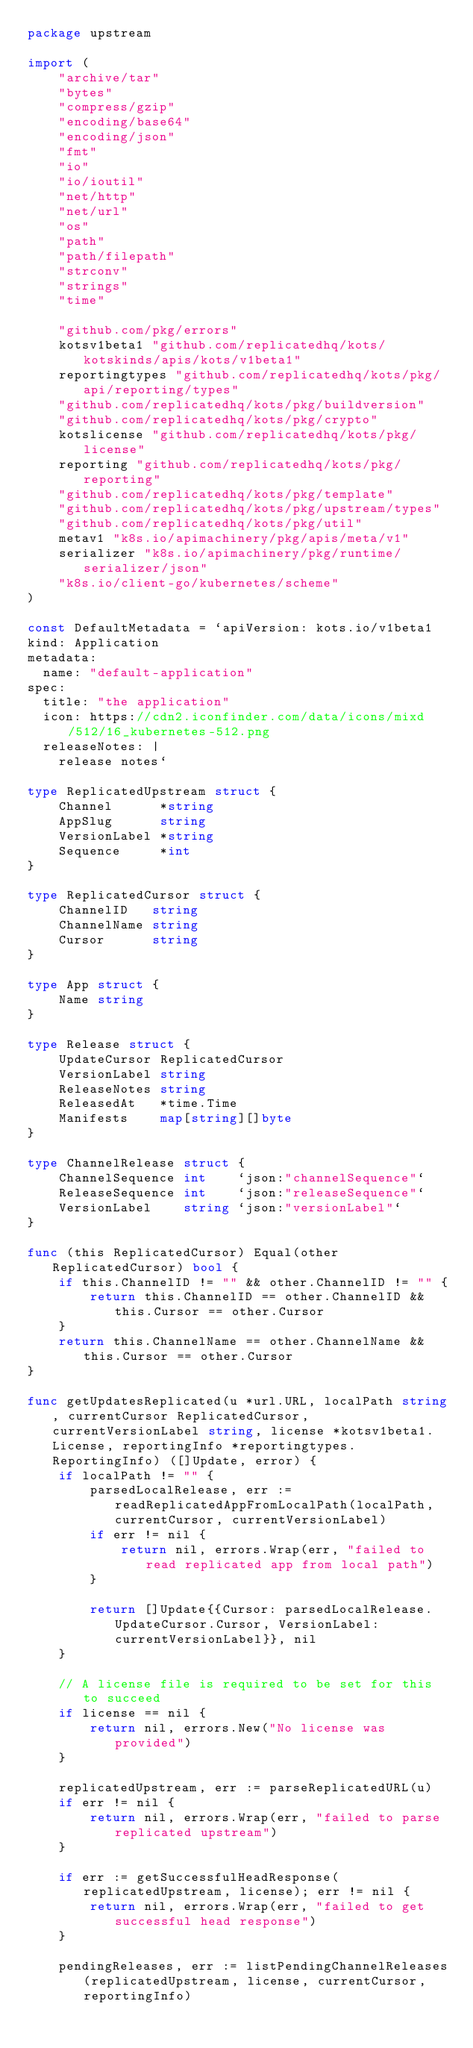Convert code to text. <code><loc_0><loc_0><loc_500><loc_500><_Go_>package upstream

import (
	"archive/tar"
	"bytes"
	"compress/gzip"
	"encoding/base64"
	"encoding/json"
	"fmt"
	"io"
	"io/ioutil"
	"net/http"
	"net/url"
	"os"
	"path"
	"path/filepath"
	"strconv"
	"strings"
	"time"

	"github.com/pkg/errors"
	kotsv1beta1 "github.com/replicatedhq/kots/kotskinds/apis/kots/v1beta1"
	reportingtypes "github.com/replicatedhq/kots/pkg/api/reporting/types"
	"github.com/replicatedhq/kots/pkg/buildversion"
	"github.com/replicatedhq/kots/pkg/crypto"
	kotslicense "github.com/replicatedhq/kots/pkg/license"
	reporting "github.com/replicatedhq/kots/pkg/reporting"
	"github.com/replicatedhq/kots/pkg/template"
	"github.com/replicatedhq/kots/pkg/upstream/types"
	"github.com/replicatedhq/kots/pkg/util"
	metav1 "k8s.io/apimachinery/pkg/apis/meta/v1"
	serializer "k8s.io/apimachinery/pkg/runtime/serializer/json"
	"k8s.io/client-go/kubernetes/scheme"
)

const DefaultMetadata = `apiVersion: kots.io/v1beta1
kind: Application
metadata:
  name: "default-application"
spec:
  title: "the application"
  icon: https://cdn2.iconfinder.com/data/icons/mixd/512/16_kubernetes-512.png
  releaseNotes: |
    release notes`

type ReplicatedUpstream struct {
	Channel      *string
	AppSlug      string
	VersionLabel *string
	Sequence     *int
}

type ReplicatedCursor struct {
	ChannelID   string
	ChannelName string
	Cursor      string
}

type App struct {
	Name string
}

type Release struct {
	UpdateCursor ReplicatedCursor
	VersionLabel string
	ReleaseNotes string
	ReleasedAt   *time.Time
	Manifests    map[string][]byte
}

type ChannelRelease struct {
	ChannelSequence int    `json:"channelSequence"`
	ReleaseSequence int    `json:"releaseSequence"`
	VersionLabel    string `json:"versionLabel"`
}

func (this ReplicatedCursor) Equal(other ReplicatedCursor) bool {
	if this.ChannelID != "" && other.ChannelID != "" {
		return this.ChannelID == other.ChannelID && this.Cursor == other.Cursor
	}
	return this.ChannelName == other.ChannelName && this.Cursor == other.Cursor
}

func getUpdatesReplicated(u *url.URL, localPath string, currentCursor ReplicatedCursor, currentVersionLabel string, license *kotsv1beta1.License, reportingInfo *reportingtypes.ReportingInfo) ([]Update, error) {
	if localPath != "" {
		parsedLocalRelease, err := readReplicatedAppFromLocalPath(localPath, currentCursor, currentVersionLabel)
		if err != nil {
			return nil, errors.Wrap(err, "failed to read replicated app from local path")
		}

		return []Update{{Cursor: parsedLocalRelease.UpdateCursor.Cursor, VersionLabel: currentVersionLabel}}, nil
	}

	// A license file is required to be set for this to succeed
	if license == nil {
		return nil, errors.New("No license was provided")
	}

	replicatedUpstream, err := parseReplicatedURL(u)
	if err != nil {
		return nil, errors.Wrap(err, "failed to parse replicated upstream")
	}

	if err := getSuccessfulHeadResponse(replicatedUpstream, license); err != nil {
		return nil, errors.Wrap(err, "failed to get successful head response")
	}

	pendingReleases, err := listPendingChannelReleases(replicatedUpstream, license, currentCursor, reportingInfo)</code> 